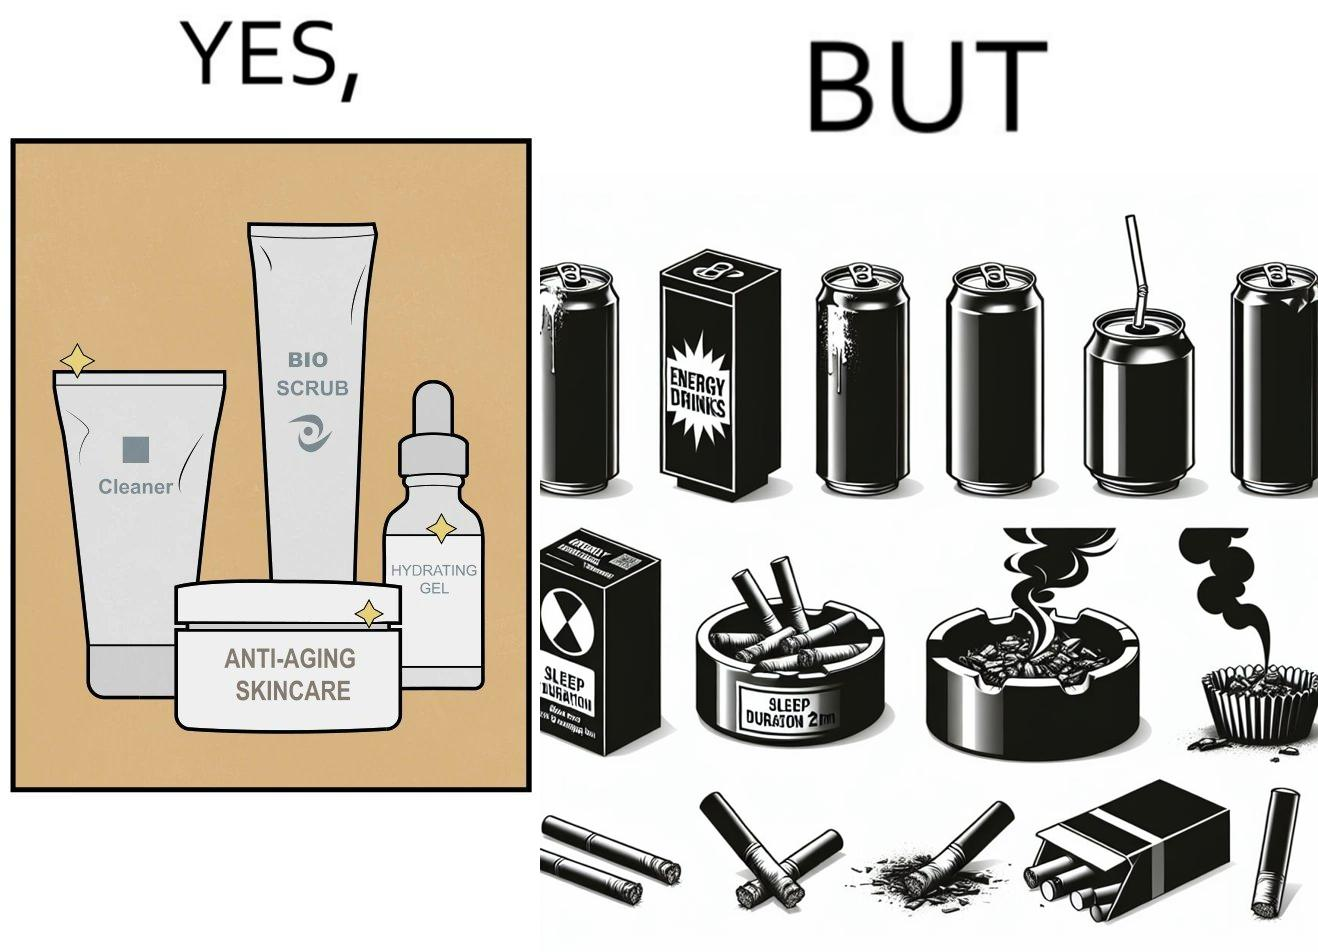Explain the humor or irony in this image. This image is ironic as on the one hand, the presumed person is into skincare and wants to do the best for their skin, which is good, but on the other hand, they are involved in unhealthy habits that will damage their skin like smoking, caffeine and inadequate sleep. 